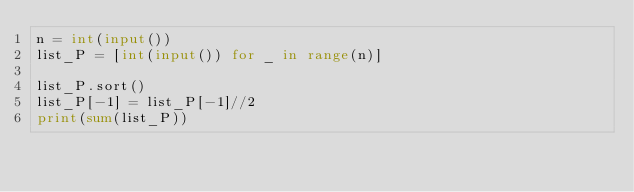<code> <loc_0><loc_0><loc_500><loc_500><_Python_>n = int(input())
list_P = [int(input()) for _ in range(n)]

list_P.sort()
list_P[-1] = list_P[-1]//2
print(sum(list_P))</code> 